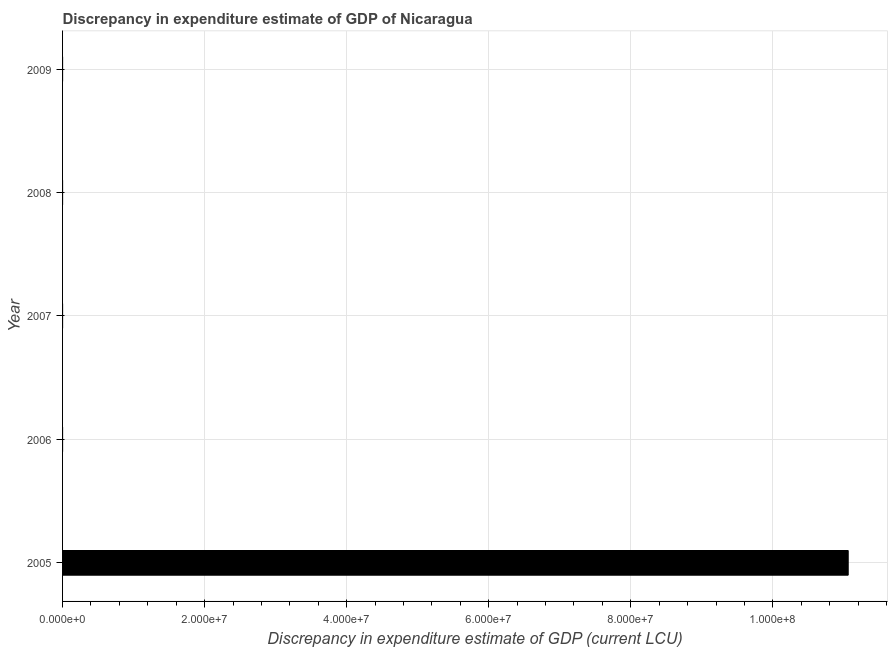What is the title of the graph?
Your answer should be compact. Discrepancy in expenditure estimate of GDP of Nicaragua. What is the label or title of the X-axis?
Offer a very short reply. Discrepancy in expenditure estimate of GDP (current LCU). What is the label or title of the Y-axis?
Your response must be concise. Year. What is the discrepancy in expenditure estimate of gdp in 2005?
Your answer should be very brief. 1.11e+08. Across all years, what is the maximum discrepancy in expenditure estimate of gdp?
Offer a very short reply. 1.11e+08. Across all years, what is the minimum discrepancy in expenditure estimate of gdp?
Offer a very short reply. 0. In which year was the discrepancy in expenditure estimate of gdp maximum?
Make the answer very short. 2005. What is the sum of the discrepancy in expenditure estimate of gdp?
Provide a succinct answer. 1.11e+08. What is the average discrepancy in expenditure estimate of gdp per year?
Your answer should be very brief. 2.21e+07. What is the ratio of the discrepancy in expenditure estimate of gdp in 2005 to that in 2007?
Provide a succinct answer. 3.37e+06. What is the difference between the highest and the lowest discrepancy in expenditure estimate of gdp?
Provide a short and direct response. 1.11e+08. Are all the bars in the graph horizontal?
Provide a succinct answer. Yes. How many years are there in the graph?
Provide a short and direct response. 5. What is the Discrepancy in expenditure estimate of GDP (current LCU) in 2005?
Your answer should be very brief. 1.11e+08. What is the Discrepancy in expenditure estimate of GDP (current LCU) of 2007?
Your response must be concise. 32.83. What is the difference between the Discrepancy in expenditure estimate of GDP (current LCU) in 2005 and 2007?
Provide a succinct answer. 1.11e+08. What is the ratio of the Discrepancy in expenditure estimate of GDP (current LCU) in 2005 to that in 2007?
Give a very brief answer. 3.37e+06. 